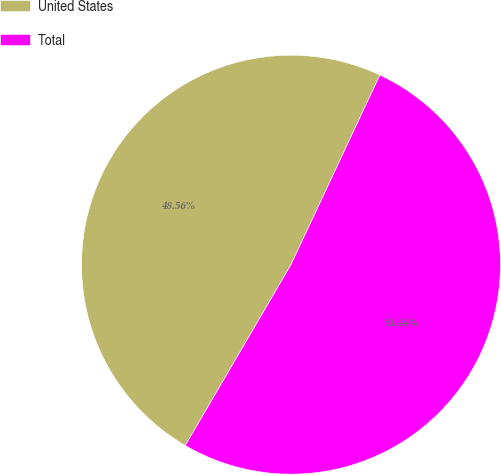Convert chart to OTSL. <chart><loc_0><loc_0><loc_500><loc_500><pie_chart><fcel>United States<fcel>Total<nl><fcel>48.56%<fcel>51.44%<nl></chart> 